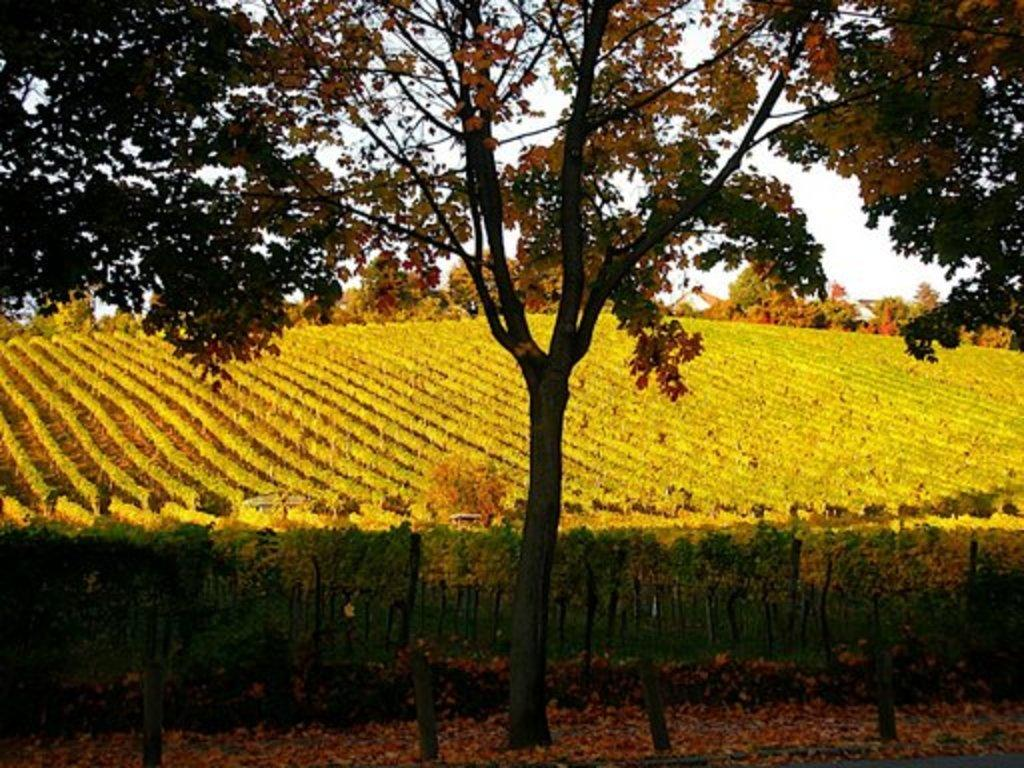What type of vegetation can be seen in the image? There are plants and trees in the image. What is the condition of the leaves on the plants in the image? There are dried leaves in the image. What is visible in the background of the image? The sky is visible in the background of the image. What type of cork can be seen in the image? There is no cork present in the image. How does the plant turn towards the sun in the image? Plants do not have the ability to turn towards the sun; they are stationary in the image. 